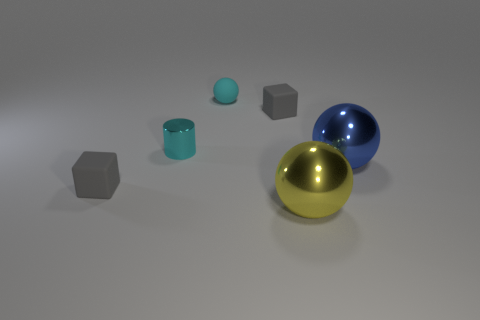Add 4 gray blocks. How many objects exist? 10 Subtract all cylinders. How many objects are left? 5 Subtract all big yellow metal cubes. Subtract all big yellow spheres. How many objects are left? 5 Add 4 small metal things. How many small metal things are left? 5 Add 4 large metallic blocks. How many large metallic blocks exist? 4 Subtract 0 yellow cubes. How many objects are left? 6 